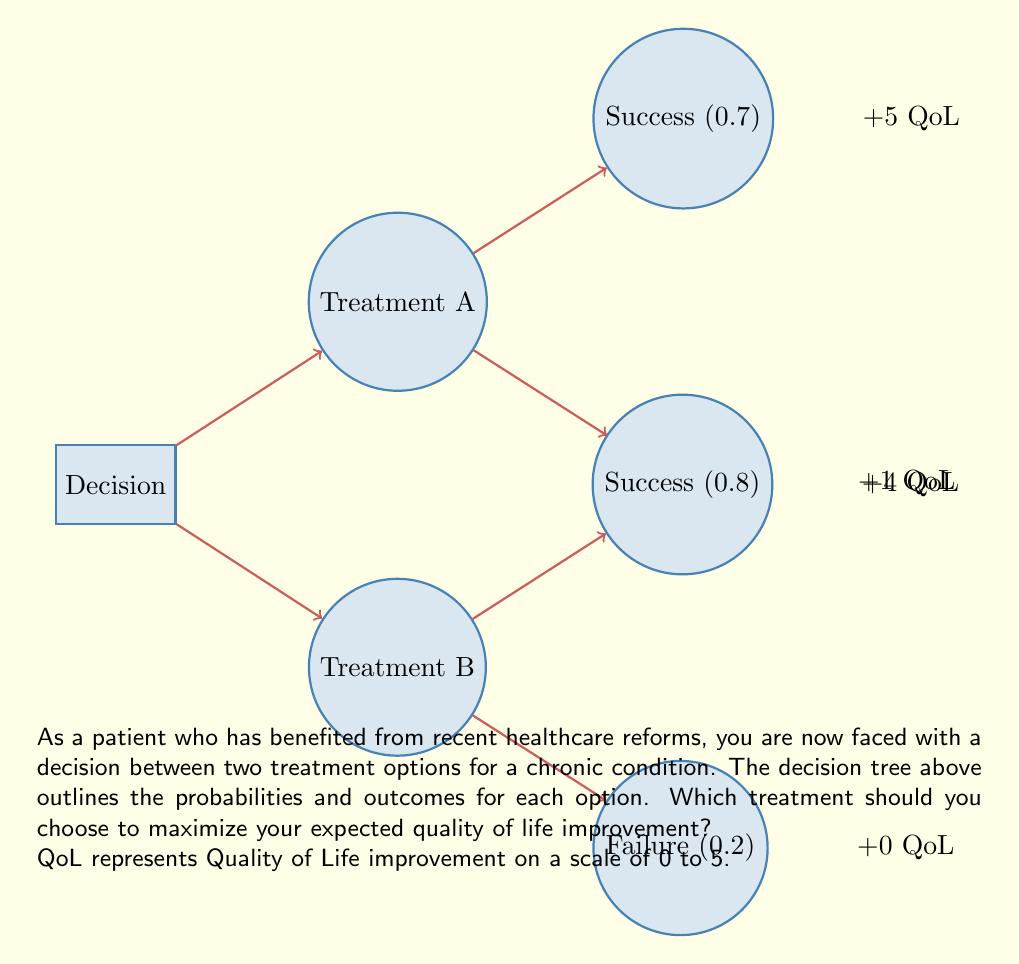Teach me how to tackle this problem. To determine the optimal decision, we need to calculate the expected value (EV) for each treatment option and choose the one with the higher EV.

For Treatment A:
1. Success probability: 0.7, Outcome: +5 QoL
2. Failure probability: 0.3, Outcome: +1 QoL

Expected Value of Treatment A:
$$EV_A = (0.7 \times 5) + (0.3 \times 1) = 3.5 + 0.3 = 3.8$$

For Treatment B:
1. Success probability: 0.8, Outcome: +4 QoL
2. Failure probability: 0.2, Outcome: +0 QoL

Expected Value of Treatment B:
$$EV_B = (0.8 \times 4) + (0.2 \times 0) = 3.2 + 0 = 3.2$$

Comparing the expected values:
$EV_A = 3.8$ is greater than $EV_B = 3.2$

Therefore, Treatment A offers a higher expected quality of life improvement.
Answer: Treatment A 